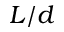<formula> <loc_0><loc_0><loc_500><loc_500>L / d</formula> 